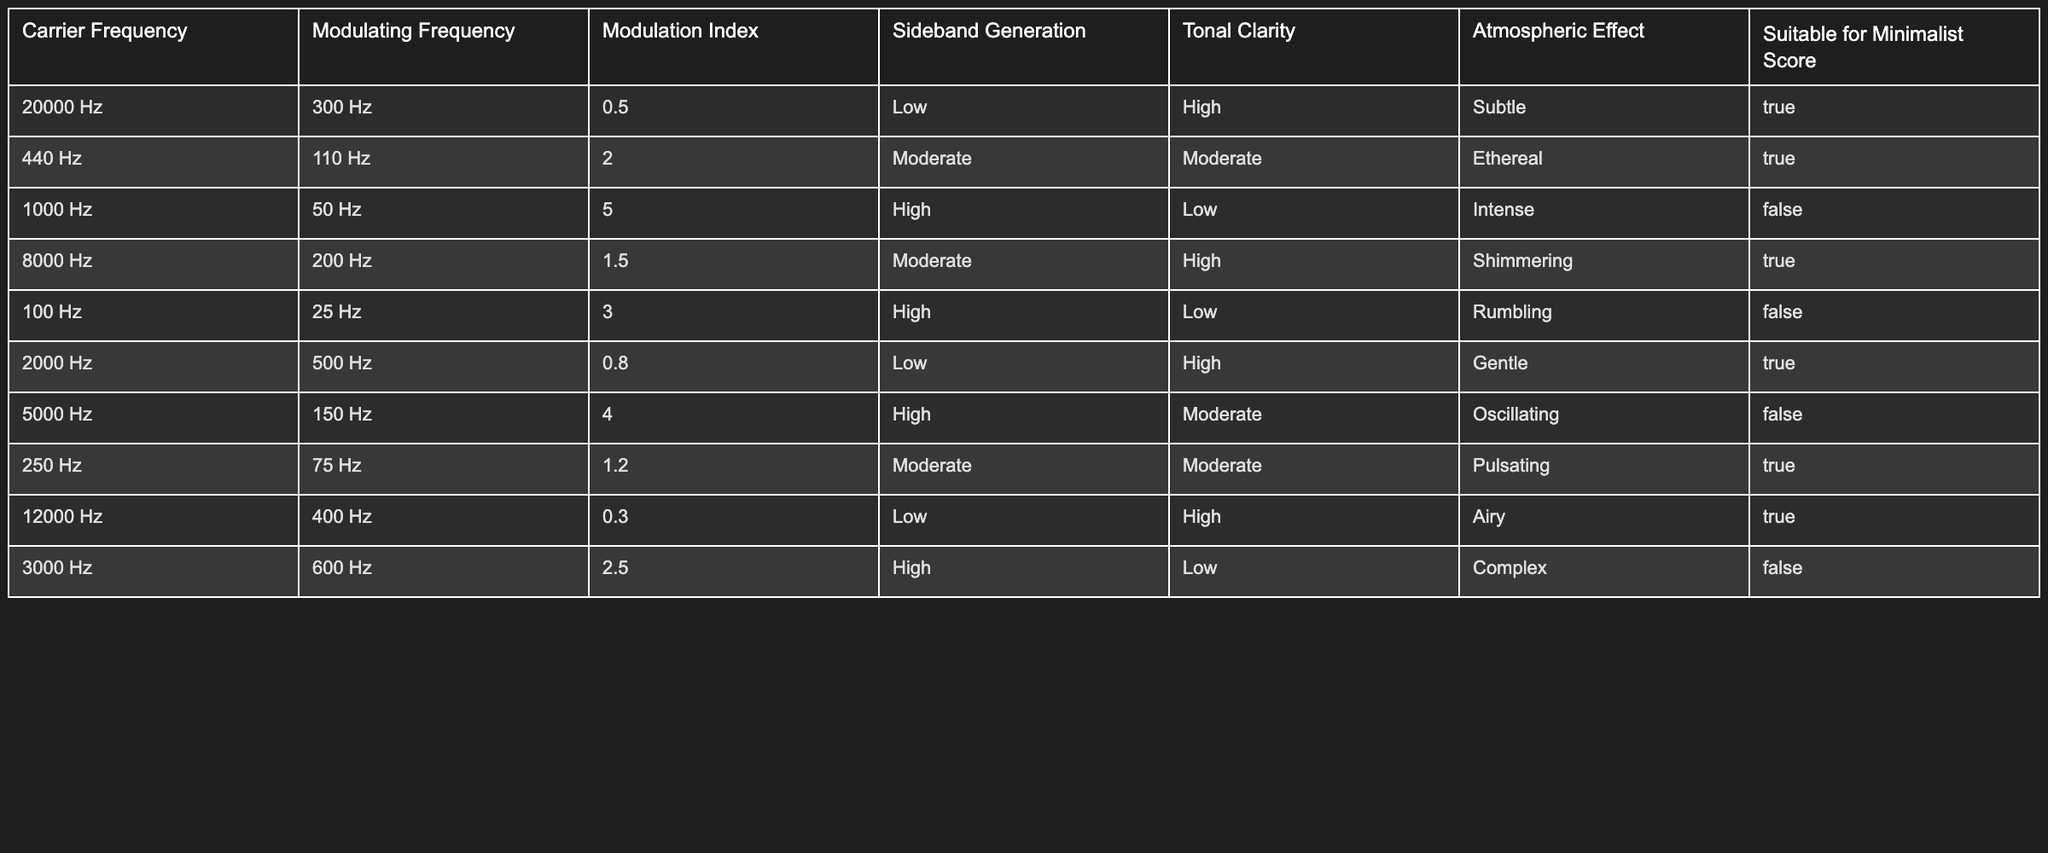What is the modulating frequency for the sound with a carrier frequency of 20000 Hz? The table shows that for the row with a carrier frequency of 20000 Hz, the corresponding modulating frequency value is 300 Hz.
Answer: 300 Hz How many sound entries have a tonal clarity rated as high? By inspecting the tonal clarity column, we see that entries with high tonal clarity are found at: 20000 Hz, 1000 Hz, 100 Hz, 2000 Hz, 12000 Hz. Counting these entries gives us a total of 5.
Answer: 5 What is the modulation index for the sound characterized by a ‘gentle’ atmospheric effect? To find this, look for the atmospheric effect labeled as 'gentle' in the table. The only entry is for a carrier frequency of 2000 Hz, which indicates a modulation index of 0.8.
Answer: 0.8 Is there any sound with a modulation index greater than 4.0 that is suitable for a minimalist score? Checking the modulation index values, the highest is 5.0 for the entry with a carrier frequency of 1000 Hz, which is not suitable for a minimalist score. Hence, the answer is no.
Answer: No What is the average modulation index of sounds suitable for a minimalist score? To calculate this, sum the modulation index values of the entries that are suitable for a minimalist score, which are 0.5, 2.0, 1.5, 0.8, and 1.2. That results in (0.5 + 2.0 + 1.5 + 0.8 + 1.2) = 6.0. Since there are 5 entries, the average modulation index is 6.0 / 5 = 1.2.
Answer: 1.2 Which sound entry has the highest sideband generation and is suitable for a minimalist score? Looking at the sideband generation column, the highest value is 'High' found at the entries for carrier frequencies of 1000 Hz, 100 Hz, 5000 Hz, and 3000 Hz. Among these, only 2000 Hz entry (regarding sideband generation) is suitable for a minimalist score.
Answer: 2000 Hz 